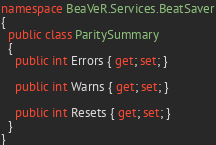<code> <loc_0><loc_0><loc_500><loc_500><_C#_>namespace BeaVeR.Services.BeatSaver
{
  public class ParitySummary
  {
    public int Errors { get; set; }

    public int Warns { get; set; }

    public int Resets { get; set; }
  }
}
</code> 